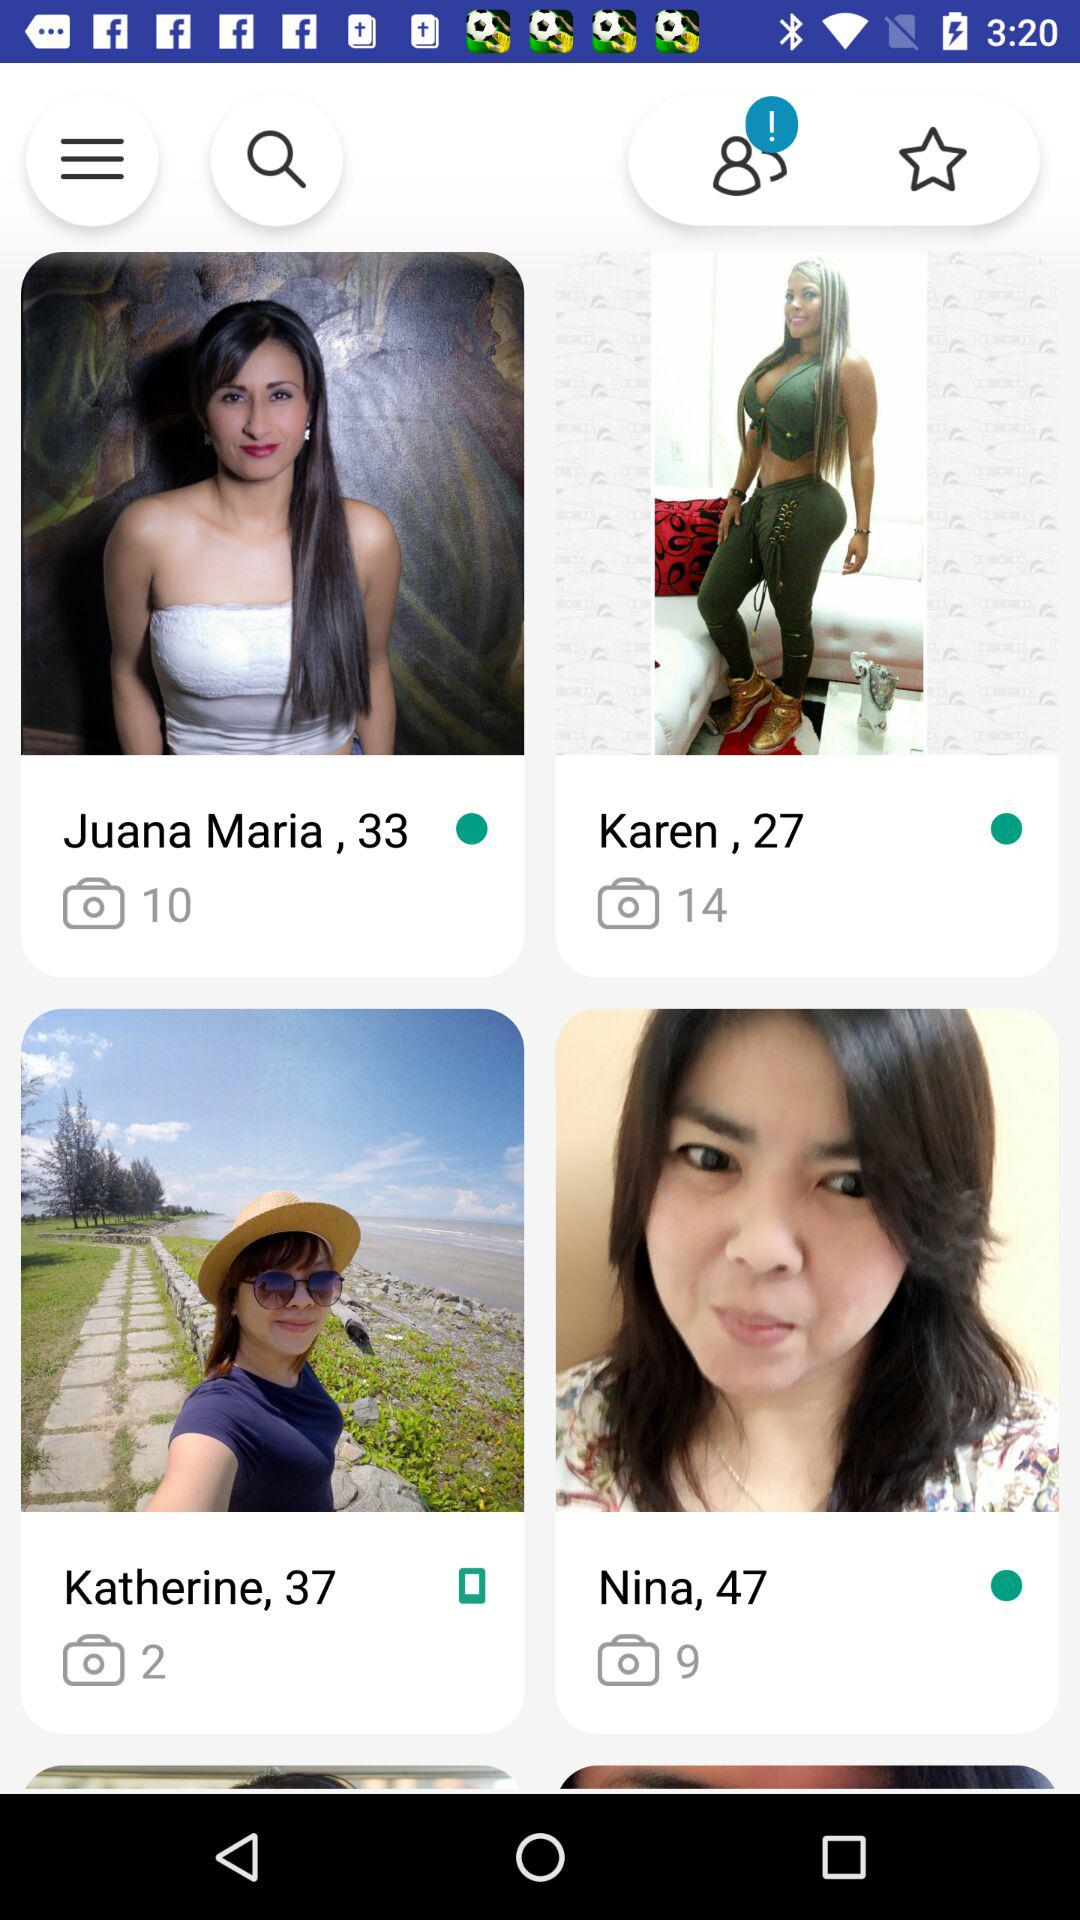In which user's gallery are two photos present? The user is Katherine. 